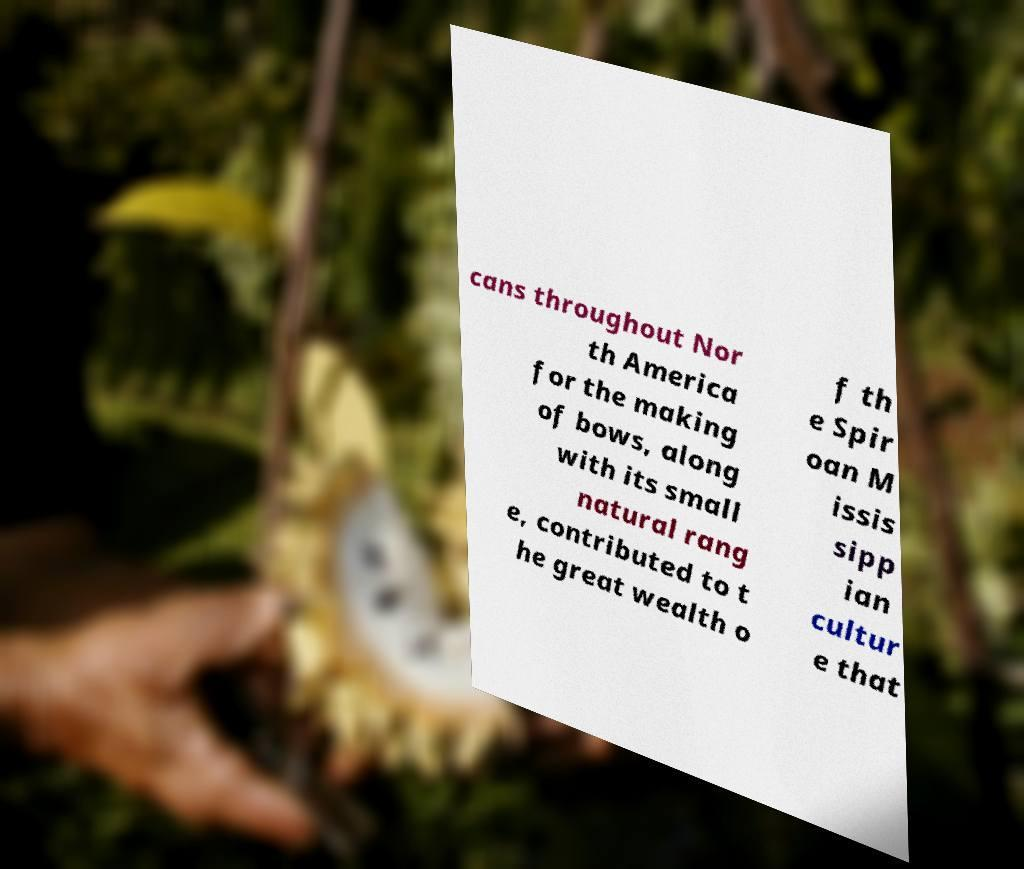Can you read and provide the text displayed in the image?This photo seems to have some interesting text. Can you extract and type it out for me? cans throughout Nor th America for the making of bows, along with its small natural rang e, contributed to t he great wealth o f th e Spir oan M issis sipp ian cultur e that 